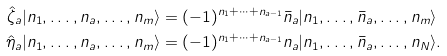Convert formula to latex. <formula><loc_0><loc_0><loc_500><loc_500>\hat { \zeta } _ { a } | n _ { 1 } , \dots , n _ { a } , \dots , n _ { m } \rangle & = ( - 1 ) ^ { n _ { 1 } + \cdots + n _ { a - 1 } } \bar { n } _ { a } | n _ { 1 } , \dots , \bar { n } _ { a } , \dots , n _ { m } \rangle \\ \hat { \eta } _ { a } | n _ { 1 } , \dots , n _ { a } , \dots , n _ { m } \rangle & = ( - 1 ) ^ { n _ { 1 } + \cdots + n _ { a - 1 } } n _ { a } | n _ { 1 } , \dots , \bar { n } _ { a } , \dots , n _ { N } \rangle .</formula> 